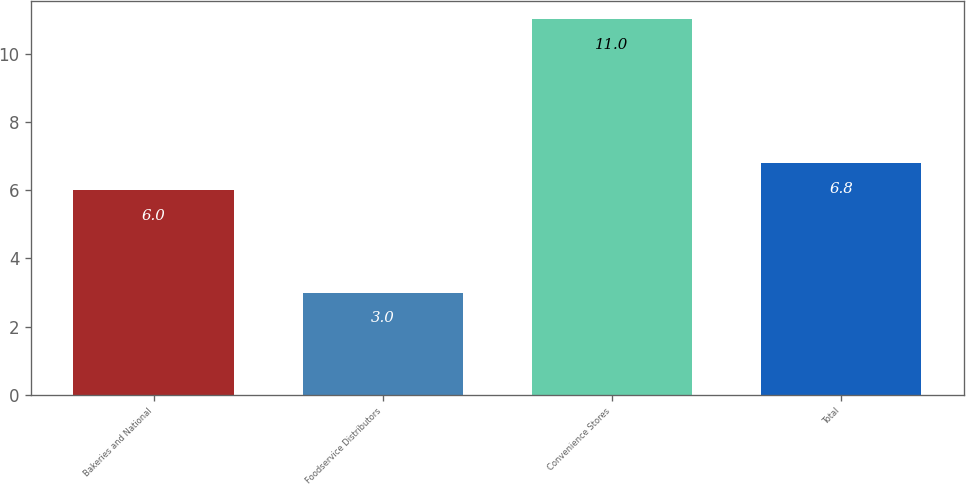Convert chart. <chart><loc_0><loc_0><loc_500><loc_500><bar_chart><fcel>Bakeries and National<fcel>Foodservice Distributors<fcel>Convenience Stores<fcel>Total<nl><fcel>6<fcel>3<fcel>11<fcel>6.8<nl></chart> 